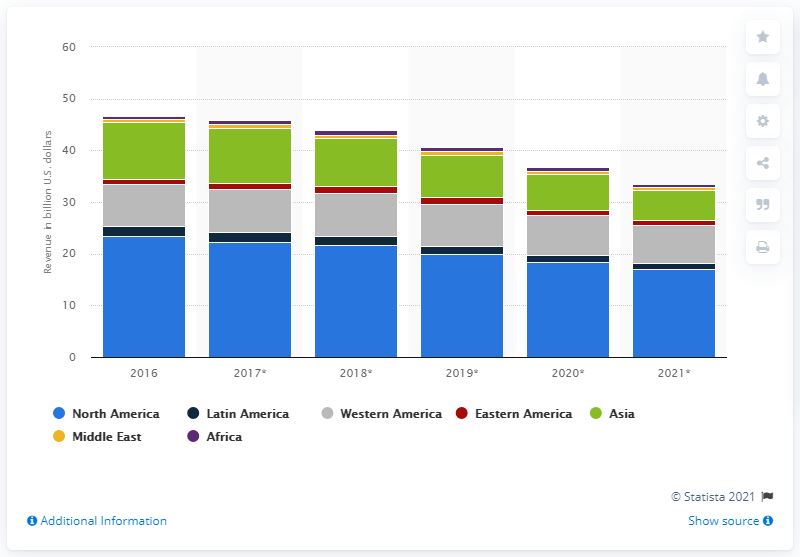Indicate a few pertinent items in this graphic. In 2016, the North American self-paced online learning market generated approximately 23.34 billion dollars in revenue. In 2021, the projected revenue of the global self-paced online learning market is expected to be 16.97... 